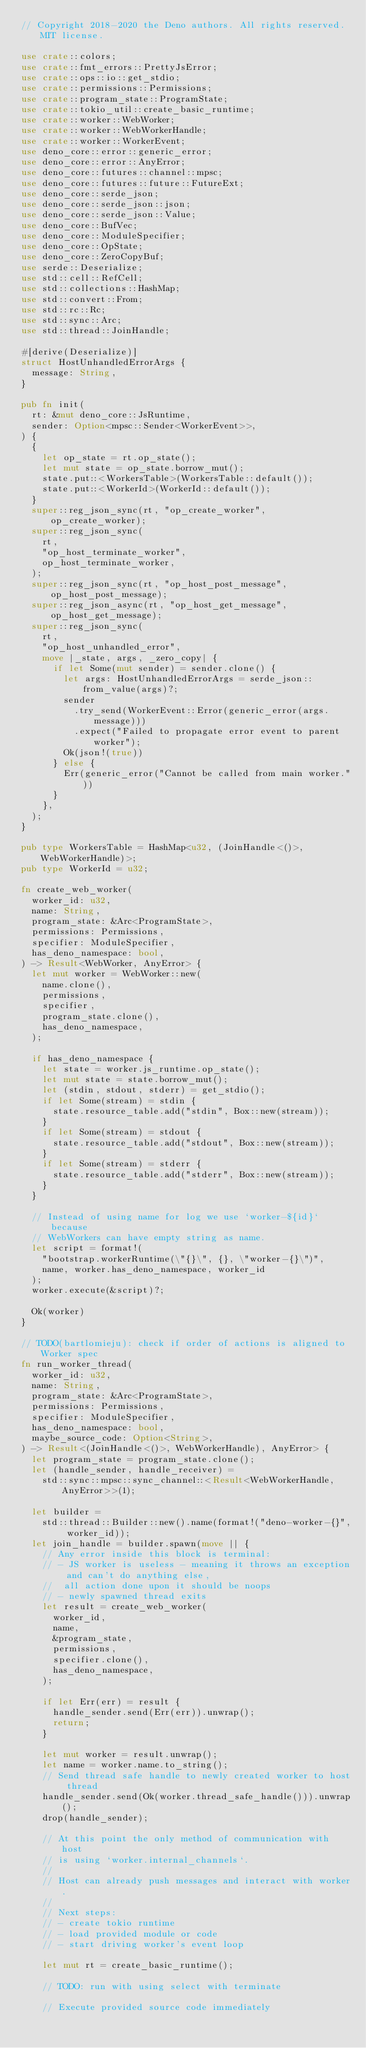<code> <loc_0><loc_0><loc_500><loc_500><_Rust_>// Copyright 2018-2020 the Deno authors. All rights reserved. MIT license.

use crate::colors;
use crate::fmt_errors::PrettyJsError;
use crate::ops::io::get_stdio;
use crate::permissions::Permissions;
use crate::program_state::ProgramState;
use crate::tokio_util::create_basic_runtime;
use crate::worker::WebWorker;
use crate::worker::WebWorkerHandle;
use crate::worker::WorkerEvent;
use deno_core::error::generic_error;
use deno_core::error::AnyError;
use deno_core::futures::channel::mpsc;
use deno_core::futures::future::FutureExt;
use deno_core::serde_json;
use deno_core::serde_json::json;
use deno_core::serde_json::Value;
use deno_core::BufVec;
use deno_core::ModuleSpecifier;
use deno_core::OpState;
use deno_core::ZeroCopyBuf;
use serde::Deserialize;
use std::cell::RefCell;
use std::collections::HashMap;
use std::convert::From;
use std::rc::Rc;
use std::sync::Arc;
use std::thread::JoinHandle;

#[derive(Deserialize)]
struct HostUnhandledErrorArgs {
  message: String,
}

pub fn init(
  rt: &mut deno_core::JsRuntime,
  sender: Option<mpsc::Sender<WorkerEvent>>,
) {
  {
    let op_state = rt.op_state();
    let mut state = op_state.borrow_mut();
    state.put::<WorkersTable>(WorkersTable::default());
    state.put::<WorkerId>(WorkerId::default());
  }
  super::reg_json_sync(rt, "op_create_worker", op_create_worker);
  super::reg_json_sync(
    rt,
    "op_host_terminate_worker",
    op_host_terminate_worker,
  );
  super::reg_json_sync(rt, "op_host_post_message", op_host_post_message);
  super::reg_json_async(rt, "op_host_get_message", op_host_get_message);
  super::reg_json_sync(
    rt,
    "op_host_unhandled_error",
    move |_state, args, _zero_copy| {
      if let Some(mut sender) = sender.clone() {
        let args: HostUnhandledErrorArgs = serde_json::from_value(args)?;
        sender
          .try_send(WorkerEvent::Error(generic_error(args.message)))
          .expect("Failed to propagate error event to parent worker");
        Ok(json!(true))
      } else {
        Err(generic_error("Cannot be called from main worker."))
      }
    },
  );
}

pub type WorkersTable = HashMap<u32, (JoinHandle<()>, WebWorkerHandle)>;
pub type WorkerId = u32;

fn create_web_worker(
  worker_id: u32,
  name: String,
  program_state: &Arc<ProgramState>,
  permissions: Permissions,
  specifier: ModuleSpecifier,
  has_deno_namespace: bool,
) -> Result<WebWorker, AnyError> {
  let mut worker = WebWorker::new(
    name.clone(),
    permissions,
    specifier,
    program_state.clone(),
    has_deno_namespace,
  );

  if has_deno_namespace {
    let state = worker.js_runtime.op_state();
    let mut state = state.borrow_mut();
    let (stdin, stdout, stderr) = get_stdio();
    if let Some(stream) = stdin {
      state.resource_table.add("stdin", Box::new(stream));
    }
    if let Some(stream) = stdout {
      state.resource_table.add("stdout", Box::new(stream));
    }
    if let Some(stream) = stderr {
      state.resource_table.add("stderr", Box::new(stream));
    }
  }

  // Instead of using name for log we use `worker-${id}` because
  // WebWorkers can have empty string as name.
  let script = format!(
    "bootstrap.workerRuntime(\"{}\", {}, \"worker-{}\")",
    name, worker.has_deno_namespace, worker_id
  );
  worker.execute(&script)?;

  Ok(worker)
}

// TODO(bartlomieju): check if order of actions is aligned to Worker spec
fn run_worker_thread(
  worker_id: u32,
  name: String,
  program_state: &Arc<ProgramState>,
  permissions: Permissions,
  specifier: ModuleSpecifier,
  has_deno_namespace: bool,
  maybe_source_code: Option<String>,
) -> Result<(JoinHandle<()>, WebWorkerHandle), AnyError> {
  let program_state = program_state.clone();
  let (handle_sender, handle_receiver) =
    std::sync::mpsc::sync_channel::<Result<WebWorkerHandle, AnyError>>(1);

  let builder =
    std::thread::Builder::new().name(format!("deno-worker-{}", worker_id));
  let join_handle = builder.spawn(move || {
    // Any error inside this block is terminal:
    // - JS worker is useless - meaning it throws an exception and can't do anything else,
    //  all action done upon it should be noops
    // - newly spawned thread exits
    let result = create_web_worker(
      worker_id,
      name,
      &program_state,
      permissions,
      specifier.clone(),
      has_deno_namespace,
    );

    if let Err(err) = result {
      handle_sender.send(Err(err)).unwrap();
      return;
    }

    let mut worker = result.unwrap();
    let name = worker.name.to_string();
    // Send thread safe handle to newly created worker to host thread
    handle_sender.send(Ok(worker.thread_safe_handle())).unwrap();
    drop(handle_sender);

    // At this point the only method of communication with host
    // is using `worker.internal_channels`.
    //
    // Host can already push messages and interact with worker.
    //
    // Next steps:
    // - create tokio runtime
    // - load provided module or code
    // - start driving worker's event loop

    let mut rt = create_basic_runtime();

    // TODO: run with using select with terminate

    // Execute provided source code immediately</code> 